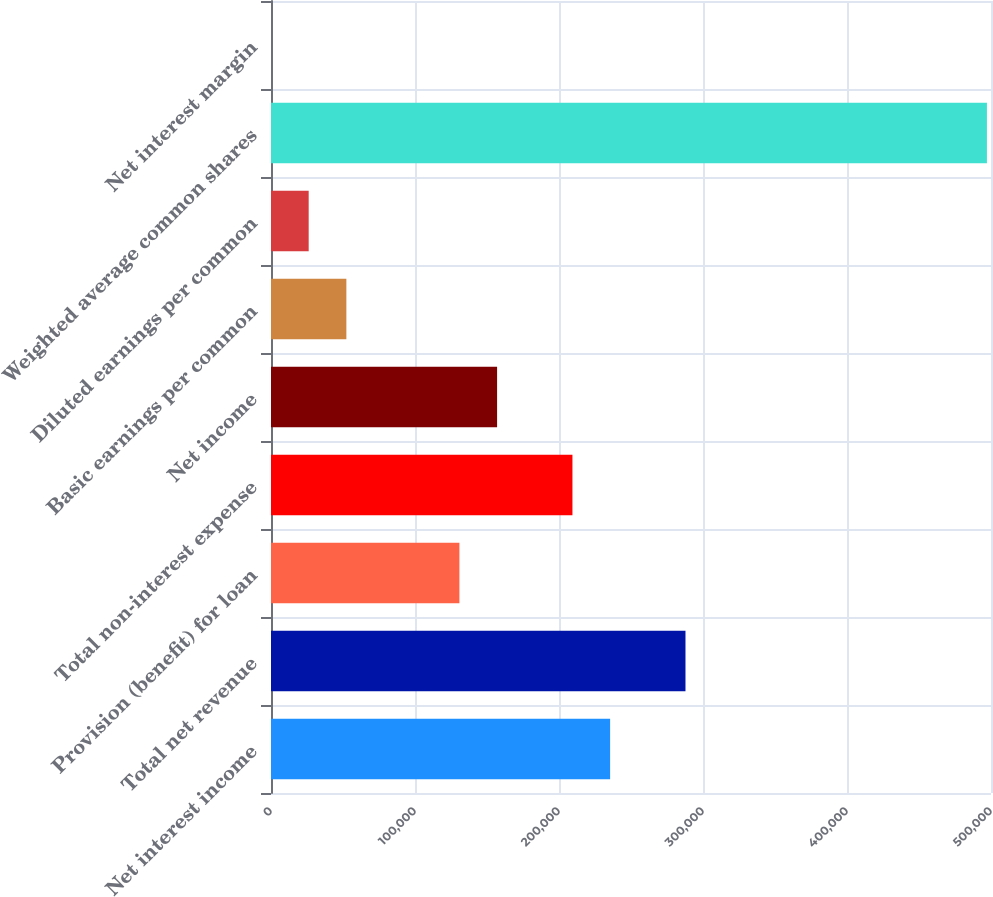<chart> <loc_0><loc_0><loc_500><loc_500><bar_chart><fcel>Net interest income<fcel>Total net revenue<fcel>Provision (benefit) for loan<fcel>Total non-interest expense<fcel>Net income<fcel>Basic earnings per common<fcel>Diluted earnings per common<fcel>Weighted average common shares<fcel>Net interest margin<nl><fcel>235502<fcel>287836<fcel>130836<fcel>209336<fcel>157003<fcel>52336.3<fcel>26169.7<fcel>497168<fcel>3.08<nl></chart> 